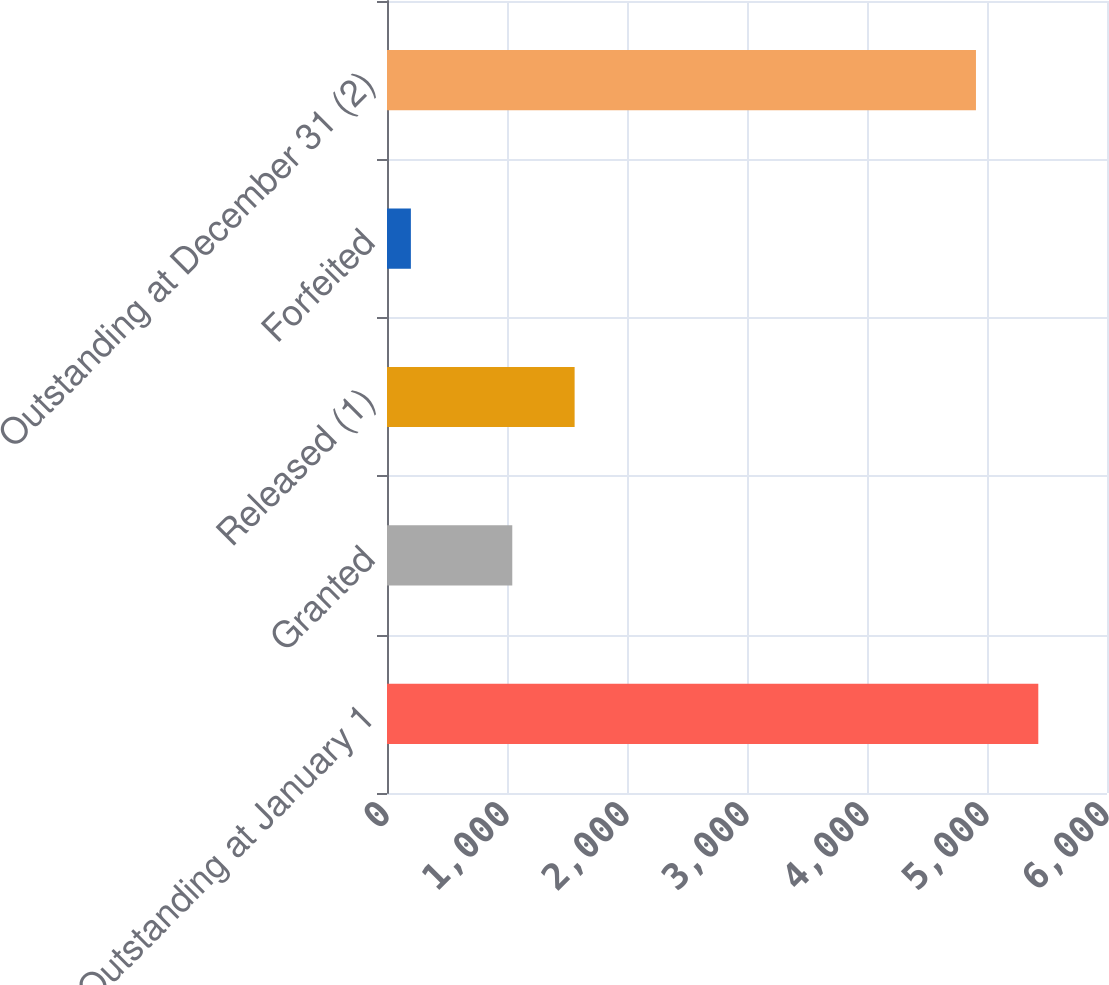Convert chart to OTSL. <chart><loc_0><loc_0><loc_500><loc_500><bar_chart><fcel>Outstanding at January 1<fcel>Granted<fcel>Released (1)<fcel>Forfeited<fcel>Outstanding at December 31 (2)<nl><fcel>5427.5<fcel>1044<fcel>1563.5<fcel>199<fcel>4908<nl></chart> 